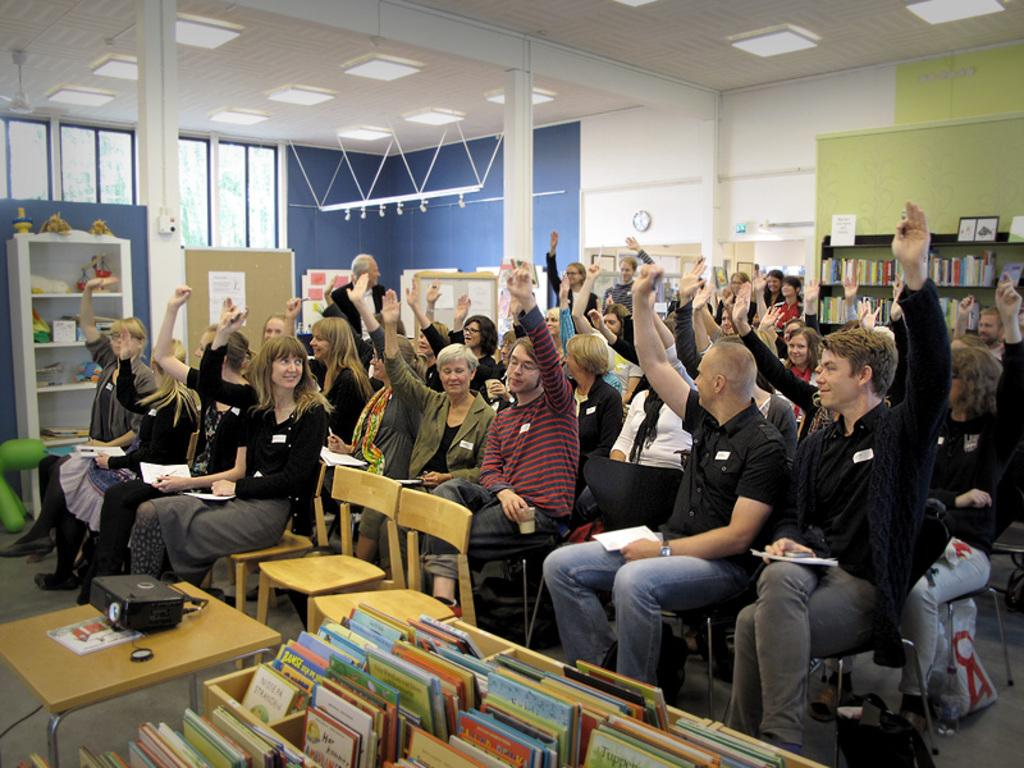What are the people in the image doing? The people in the image are sitting on chairs and raising their hands. What might be the purpose of raising their hands? It is unclear from the image alone, but it could be to answer a question, participate in a discussion, or signal agreement. What objects are in front of the people? There are books in front of the people. What type of animals can be seen at the zoo in the image? There is no zoo or animals present in the image; it features people sitting on chairs and raising their hands with books in front of them. 